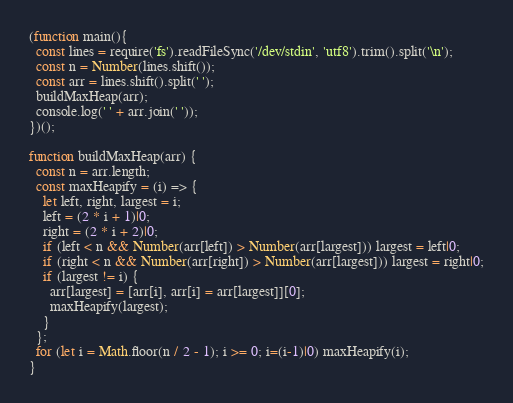<code> <loc_0><loc_0><loc_500><loc_500><_JavaScript_>(function main(){
  const lines = require('fs').readFileSync('/dev/stdin', 'utf8').trim().split('\n');
  const n = Number(lines.shift());
  const arr = lines.shift().split(' ');
  buildMaxHeap(arr);
  console.log(' ' + arr.join(' '));
})();

function buildMaxHeap(arr) {
  const n = arr.length;
  const maxHeapify = (i) => {
    let left, right, largest = i;
    left = (2 * i + 1)|0;
    right = (2 * i + 2)|0;
    if (left < n && Number(arr[left]) > Number(arr[largest])) largest = left|0;
    if (right < n && Number(arr[right]) > Number(arr[largest])) largest = right|0;
    if (largest != i) {
      arr[largest] = [arr[i], arr[i] = arr[largest]][0];
      maxHeapify(largest);
    }
  };
  for (let i = Math.floor(n / 2 - 1); i >= 0; i=(i-1)|0) maxHeapify(i);
}

</code> 